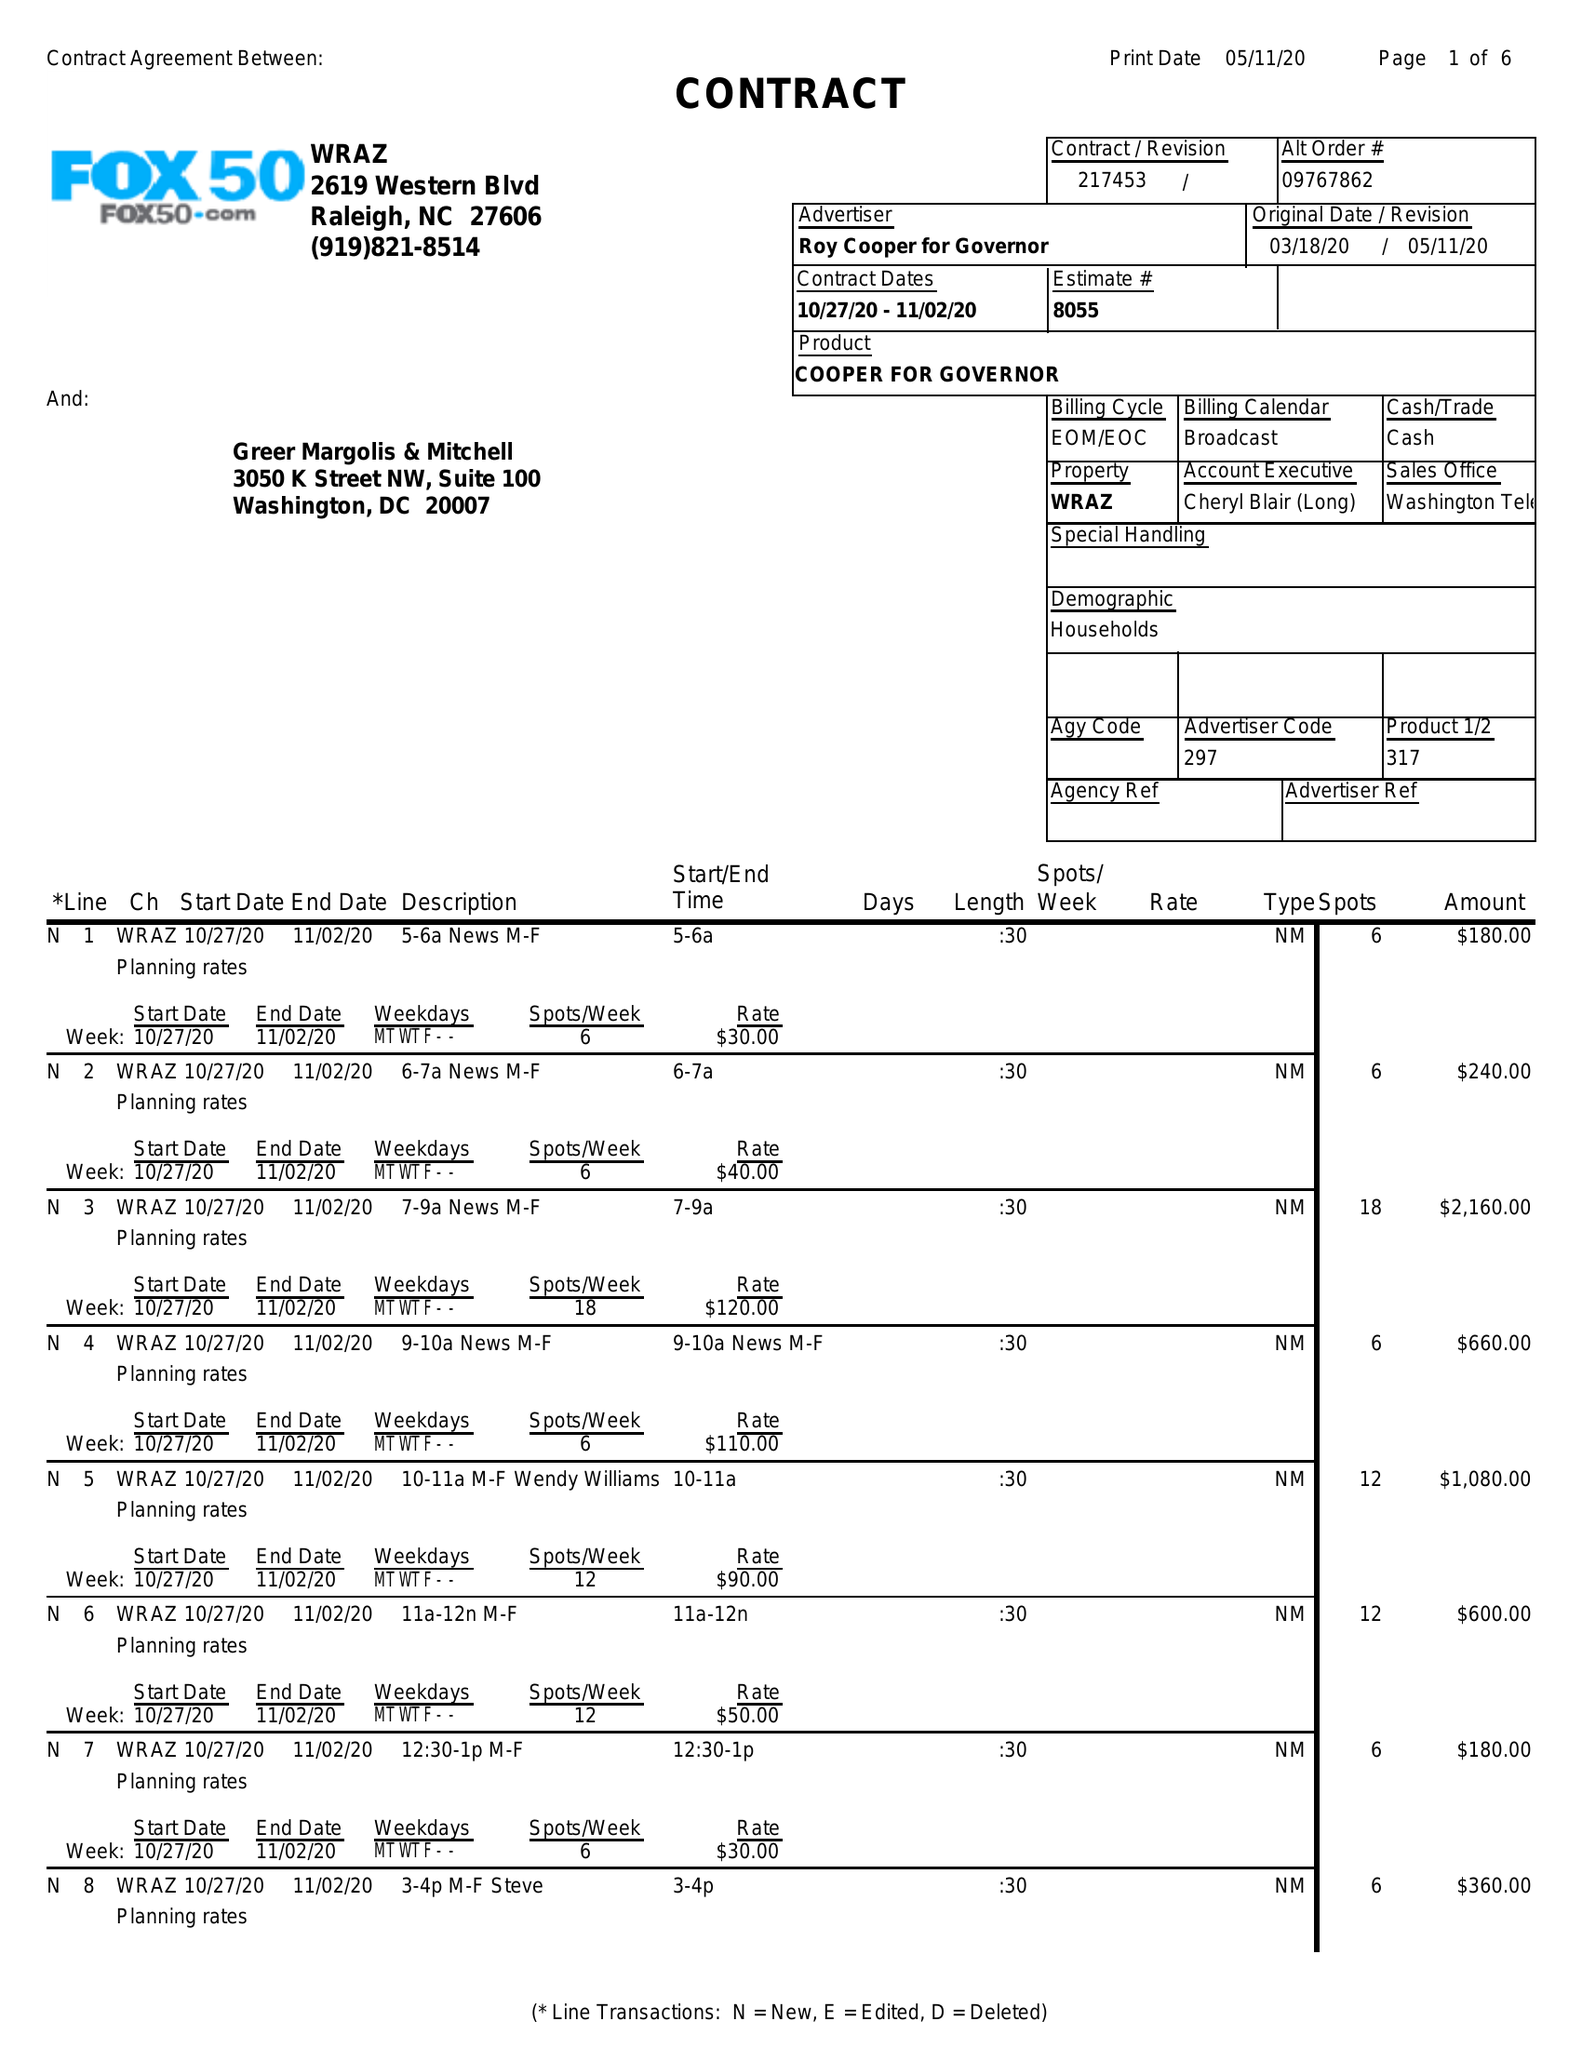What is the value for the gross_amount?
Answer the question using a single word or phrase. 49880.00 